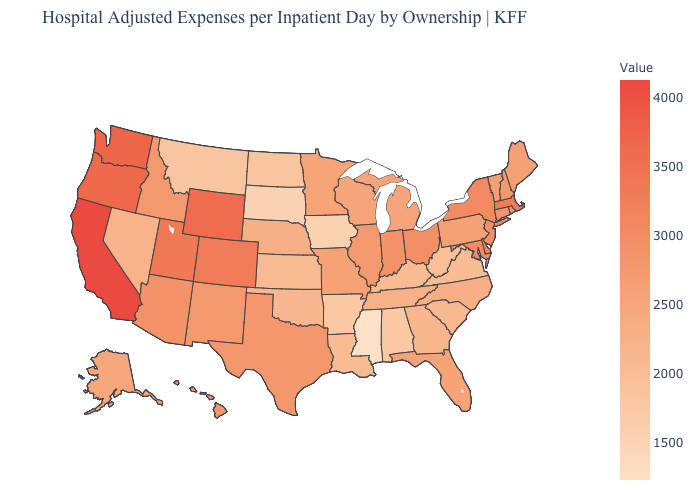Among the states that border Utah , which have the highest value?
Quick response, please. Wyoming. Which states have the highest value in the USA?
Keep it brief. California. Which states have the highest value in the USA?
Quick response, please. California. Among the states that border Delaware , does Pennsylvania have the highest value?
Write a very short answer. No. Does Rhode Island have a lower value than Nebraska?
Quick response, please. No. Among the states that border Wisconsin , which have the lowest value?
Be succinct. Iowa. Does Nebraska have the lowest value in the USA?
Be succinct. No. Does Missouri have a lower value than Mississippi?
Short answer required. No. 